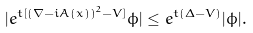Convert formula to latex. <formula><loc_0><loc_0><loc_500><loc_500>| e ^ { t [ ( \nabla - i A ( x ) ) ^ { 2 } - V ] } \phi | \leq e ^ { t ( \Delta - V ) } | \phi | .</formula> 